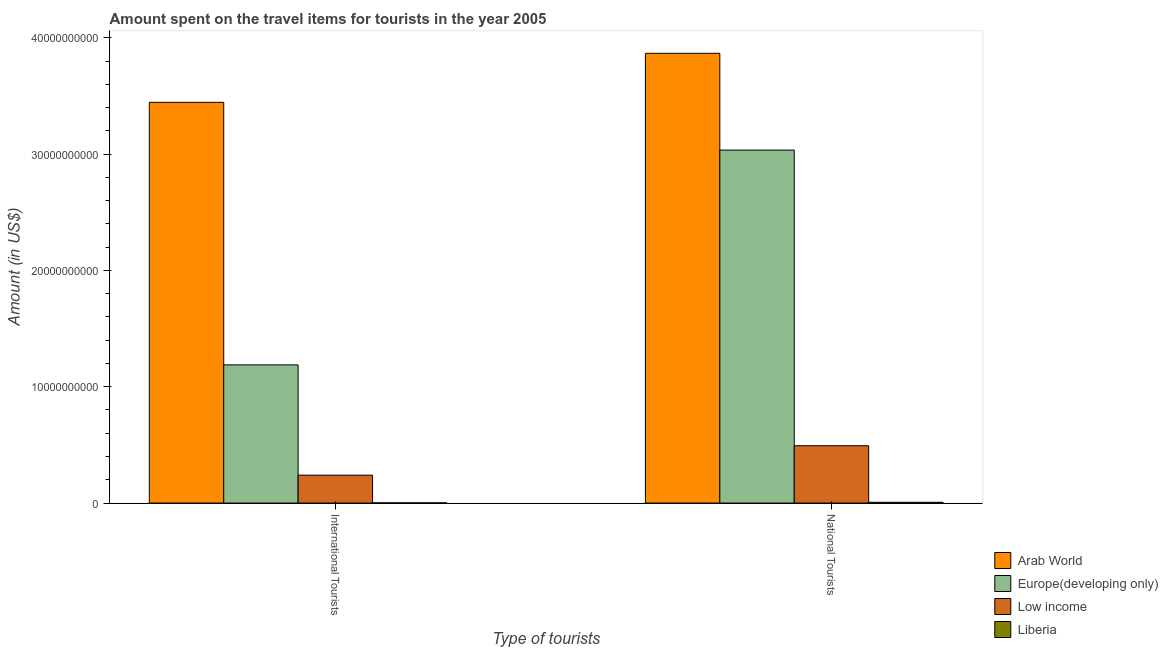How many groups of bars are there?
Make the answer very short. 2. Are the number of bars per tick equal to the number of legend labels?
Give a very brief answer. Yes. Are the number of bars on each tick of the X-axis equal?
Offer a very short reply. Yes. How many bars are there on the 1st tick from the left?
Provide a succinct answer. 4. How many bars are there on the 2nd tick from the right?
Provide a succinct answer. 4. What is the label of the 1st group of bars from the left?
Provide a succinct answer. International Tourists. What is the amount spent on travel items of national tourists in Liberia?
Your answer should be compact. 6.70e+07. Across all countries, what is the maximum amount spent on travel items of international tourists?
Your answer should be compact. 3.44e+1. Across all countries, what is the minimum amount spent on travel items of national tourists?
Provide a succinct answer. 6.70e+07. In which country was the amount spent on travel items of international tourists maximum?
Offer a terse response. Arab World. In which country was the amount spent on travel items of international tourists minimum?
Offer a terse response. Liberia. What is the total amount spent on travel items of national tourists in the graph?
Your response must be concise. 7.40e+1. What is the difference between the amount spent on travel items of international tourists in Low income and that in Liberia?
Keep it short and to the point. 2.38e+09. What is the difference between the amount spent on travel items of international tourists in Arab World and the amount spent on travel items of national tourists in Low income?
Keep it short and to the point. 2.95e+1. What is the average amount spent on travel items of national tourists per country?
Your response must be concise. 1.85e+1. What is the difference between the amount spent on travel items of national tourists and amount spent on travel items of international tourists in Low income?
Keep it short and to the point. 2.53e+09. In how many countries, is the amount spent on travel items of international tourists greater than 10000000000 US$?
Provide a succinct answer. 2. What is the ratio of the amount spent on travel items of international tourists in Liberia to that in Arab World?
Your answer should be compact. 0. Is the amount spent on travel items of national tourists in Liberia less than that in Europe(developing only)?
Give a very brief answer. Yes. In how many countries, is the amount spent on travel items of national tourists greater than the average amount spent on travel items of national tourists taken over all countries?
Offer a very short reply. 2. What does the 4th bar from the left in International Tourists represents?
Keep it short and to the point. Liberia. What does the 2nd bar from the right in International Tourists represents?
Offer a very short reply. Low income. Are the values on the major ticks of Y-axis written in scientific E-notation?
Your response must be concise. No. Does the graph contain any zero values?
Your answer should be compact. No. How are the legend labels stacked?
Make the answer very short. Vertical. What is the title of the graph?
Give a very brief answer. Amount spent on the travel items for tourists in the year 2005. Does "Liberia" appear as one of the legend labels in the graph?
Your answer should be very brief. Yes. What is the label or title of the X-axis?
Provide a short and direct response. Type of tourists. What is the Amount (in US$) in Arab World in International Tourists?
Your answer should be very brief. 3.44e+1. What is the Amount (in US$) in Europe(developing only) in International Tourists?
Make the answer very short. 1.19e+1. What is the Amount (in US$) of Low income in International Tourists?
Keep it short and to the point. 2.40e+09. What is the Amount (in US$) in Liberia in International Tourists?
Ensure brevity in your answer.  1.60e+07. What is the Amount (in US$) of Arab World in National Tourists?
Give a very brief answer. 3.87e+1. What is the Amount (in US$) of Europe(developing only) in National Tourists?
Give a very brief answer. 3.03e+1. What is the Amount (in US$) of Low income in National Tourists?
Your response must be concise. 4.93e+09. What is the Amount (in US$) in Liberia in National Tourists?
Provide a short and direct response. 6.70e+07. Across all Type of tourists, what is the maximum Amount (in US$) in Arab World?
Keep it short and to the point. 3.87e+1. Across all Type of tourists, what is the maximum Amount (in US$) of Europe(developing only)?
Give a very brief answer. 3.03e+1. Across all Type of tourists, what is the maximum Amount (in US$) in Low income?
Ensure brevity in your answer.  4.93e+09. Across all Type of tourists, what is the maximum Amount (in US$) of Liberia?
Keep it short and to the point. 6.70e+07. Across all Type of tourists, what is the minimum Amount (in US$) in Arab World?
Your response must be concise. 3.44e+1. Across all Type of tourists, what is the minimum Amount (in US$) in Europe(developing only)?
Provide a short and direct response. 1.19e+1. Across all Type of tourists, what is the minimum Amount (in US$) of Low income?
Give a very brief answer. 2.40e+09. Across all Type of tourists, what is the minimum Amount (in US$) in Liberia?
Make the answer very short. 1.60e+07. What is the total Amount (in US$) in Arab World in the graph?
Your response must be concise. 7.31e+1. What is the total Amount (in US$) of Europe(developing only) in the graph?
Offer a terse response. 4.22e+1. What is the total Amount (in US$) of Low income in the graph?
Provide a succinct answer. 7.32e+09. What is the total Amount (in US$) in Liberia in the graph?
Ensure brevity in your answer.  8.30e+07. What is the difference between the Amount (in US$) of Arab World in International Tourists and that in National Tourists?
Offer a terse response. -4.21e+09. What is the difference between the Amount (in US$) of Europe(developing only) in International Tourists and that in National Tourists?
Provide a short and direct response. -1.85e+1. What is the difference between the Amount (in US$) of Low income in International Tourists and that in National Tourists?
Your response must be concise. -2.53e+09. What is the difference between the Amount (in US$) in Liberia in International Tourists and that in National Tourists?
Provide a short and direct response. -5.10e+07. What is the difference between the Amount (in US$) of Arab World in International Tourists and the Amount (in US$) of Europe(developing only) in National Tourists?
Keep it short and to the point. 4.11e+09. What is the difference between the Amount (in US$) in Arab World in International Tourists and the Amount (in US$) in Low income in National Tourists?
Your answer should be compact. 2.95e+1. What is the difference between the Amount (in US$) of Arab World in International Tourists and the Amount (in US$) of Liberia in National Tourists?
Make the answer very short. 3.44e+1. What is the difference between the Amount (in US$) of Europe(developing only) in International Tourists and the Amount (in US$) of Low income in National Tourists?
Provide a short and direct response. 6.95e+09. What is the difference between the Amount (in US$) in Europe(developing only) in International Tourists and the Amount (in US$) in Liberia in National Tourists?
Give a very brief answer. 1.18e+1. What is the difference between the Amount (in US$) in Low income in International Tourists and the Amount (in US$) in Liberia in National Tourists?
Make the answer very short. 2.33e+09. What is the average Amount (in US$) of Arab World per Type of tourists?
Ensure brevity in your answer.  3.66e+1. What is the average Amount (in US$) of Europe(developing only) per Type of tourists?
Keep it short and to the point. 2.11e+1. What is the average Amount (in US$) in Low income per Type of tourists?
Provide a short and direct response. 3.66e+09. What is the average Amount (in US$) in Liberia per Type of tourists?
Provide a succinct answer. 4.15e+07. What is the difference between the Amount (in US$) in Arab World and Amount (in US$) in Europe(developing only) in International Tourists?
Offer a terse response. 2.26e+1. What is the difference between the Amount (in US$) of Arab World and Amount (in US$) of Low income in International Tourists?
Offer a very short reply. 3.21e+1. What is the difference between the Amount (in US$) of Arab World and Amount (in US$) of Liberia in International Tourists?
Offer a terse response. 3.44e+1. What is the difference between the Amount (in US$) of Europe(developing only) and Amount (in US$) of Low income in International Tourists?
Make the answer very short. 9.48e+09. What is the difference between the Amount (in US$) of Europe(developing only) and Amount (in US$) of Liberia in International Tourists?
Give a very brief answer. 1.19e+1. What is the difference between the Amount (in US$) in Low income and Amount (in US$) in Liberia in International Tourists?
Ensure brevity in your answer.  2.38e+09. What is the difference between the Amount (in US$) in Arab World and Amount (in US$) in Europe(developing only) in National Tourists?
Give a very brief answer. 8.32e+09. What is the difference between the Amount (in US$) in Arab World and Amount (in US$) in Low income in National Tourists?
Provide a short and direct response. 3.37e+1. What is the difference between the Amount (in US$) of Arab World and Amount (in US$) of Liberia in National Tourists?
Your response must be concise. 3.86e+1. What is the difference between the Amount (in US$) in Europe(developing only) and Amount (in US$) in Low income in National Tourists?
Your answer should be compact. 2.54e+1. What is the difference between the Amount (in US$) of Europe(developing only) and Amount (in US$) of Liberia in National Tourists?
Provide a succinct answer. 3.03e+1. What is the difference between the Amount (in US$) in Low income and Amount (in US$) in Liberia in National Tourists?
Ensure brevity in your answer.  4.86e+09. What is the ratio of the Amount (in US$) of Arab World in International Tourists to that in National Tourists?
Provide a short and direct response. 0.89. What is the ratio of the Amount (in US$) in Europe(developing only) in International Tourists to that in National Tourists?
Provide a succinct answer. 0.39. What is the ratio of the Amount (in US$) in Low income in International Tourists to that in National Tourists?
Ensure brevity in your answer.  0.49. What is the ratio of the Amount (in US$) in Liberia in International Tourists to that in National Tourists?
Offer a very short reply. 0.24. What is the difference between the highest and the second highest Amount (in US$) of Arab World?
Offer a terse response. 4.21e+09. What is the difference between the highest and the second highest Amount (in US$) in Europe(developing only)?
Provide a succinct answer. 1.85e+1. What is the difference between the highest and the second highest Amount (in US$) of Low income?
Give a very brief answer. 2.53e+09. What is the difference between the highest and the second highest Amount (in US$) in Liberia?
Offer a terse response. 5.10e+07. What is the difference between the highest and the lowest Amount (in US$) in Arab World?
Give a very brief answer. 4.21e+09. What is the difference between the highest and the lowest Amount (in US$) of Europe(developing only)?
Offer a terse response. 1.85e+1. What is the difference between the highest and the lowest Amount (in US$) in Low income?
Your answer should be compact. 2.53e+09. What is the difference between the highest and the lowest Amount (in US$) of Liberia?
Your answer should be very brief. 5.10e+07. 